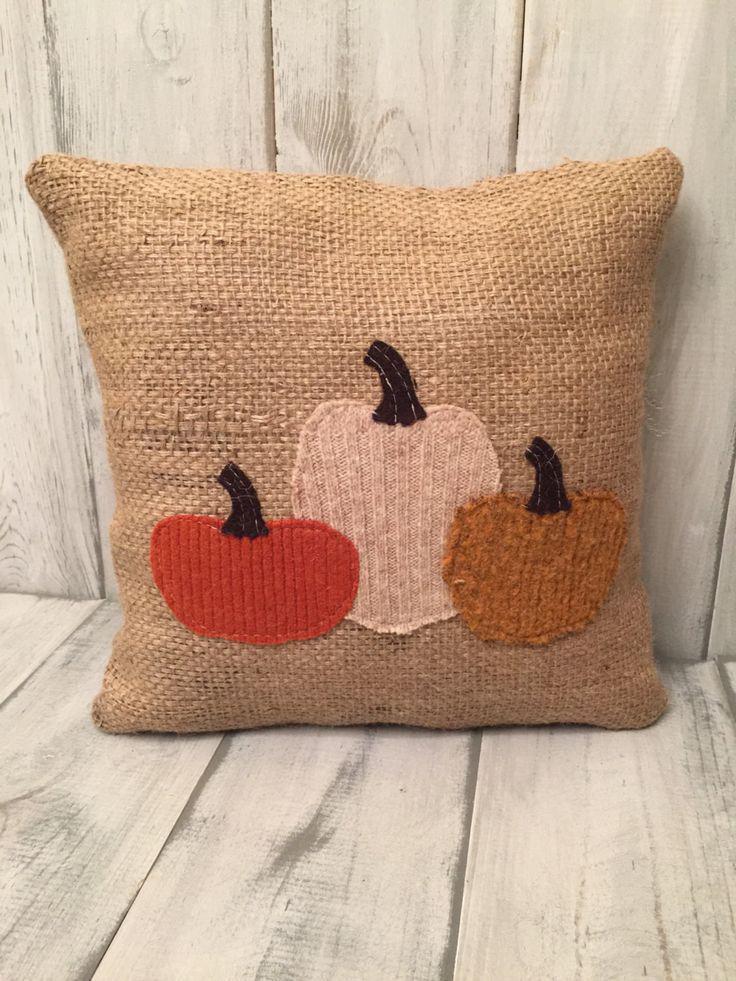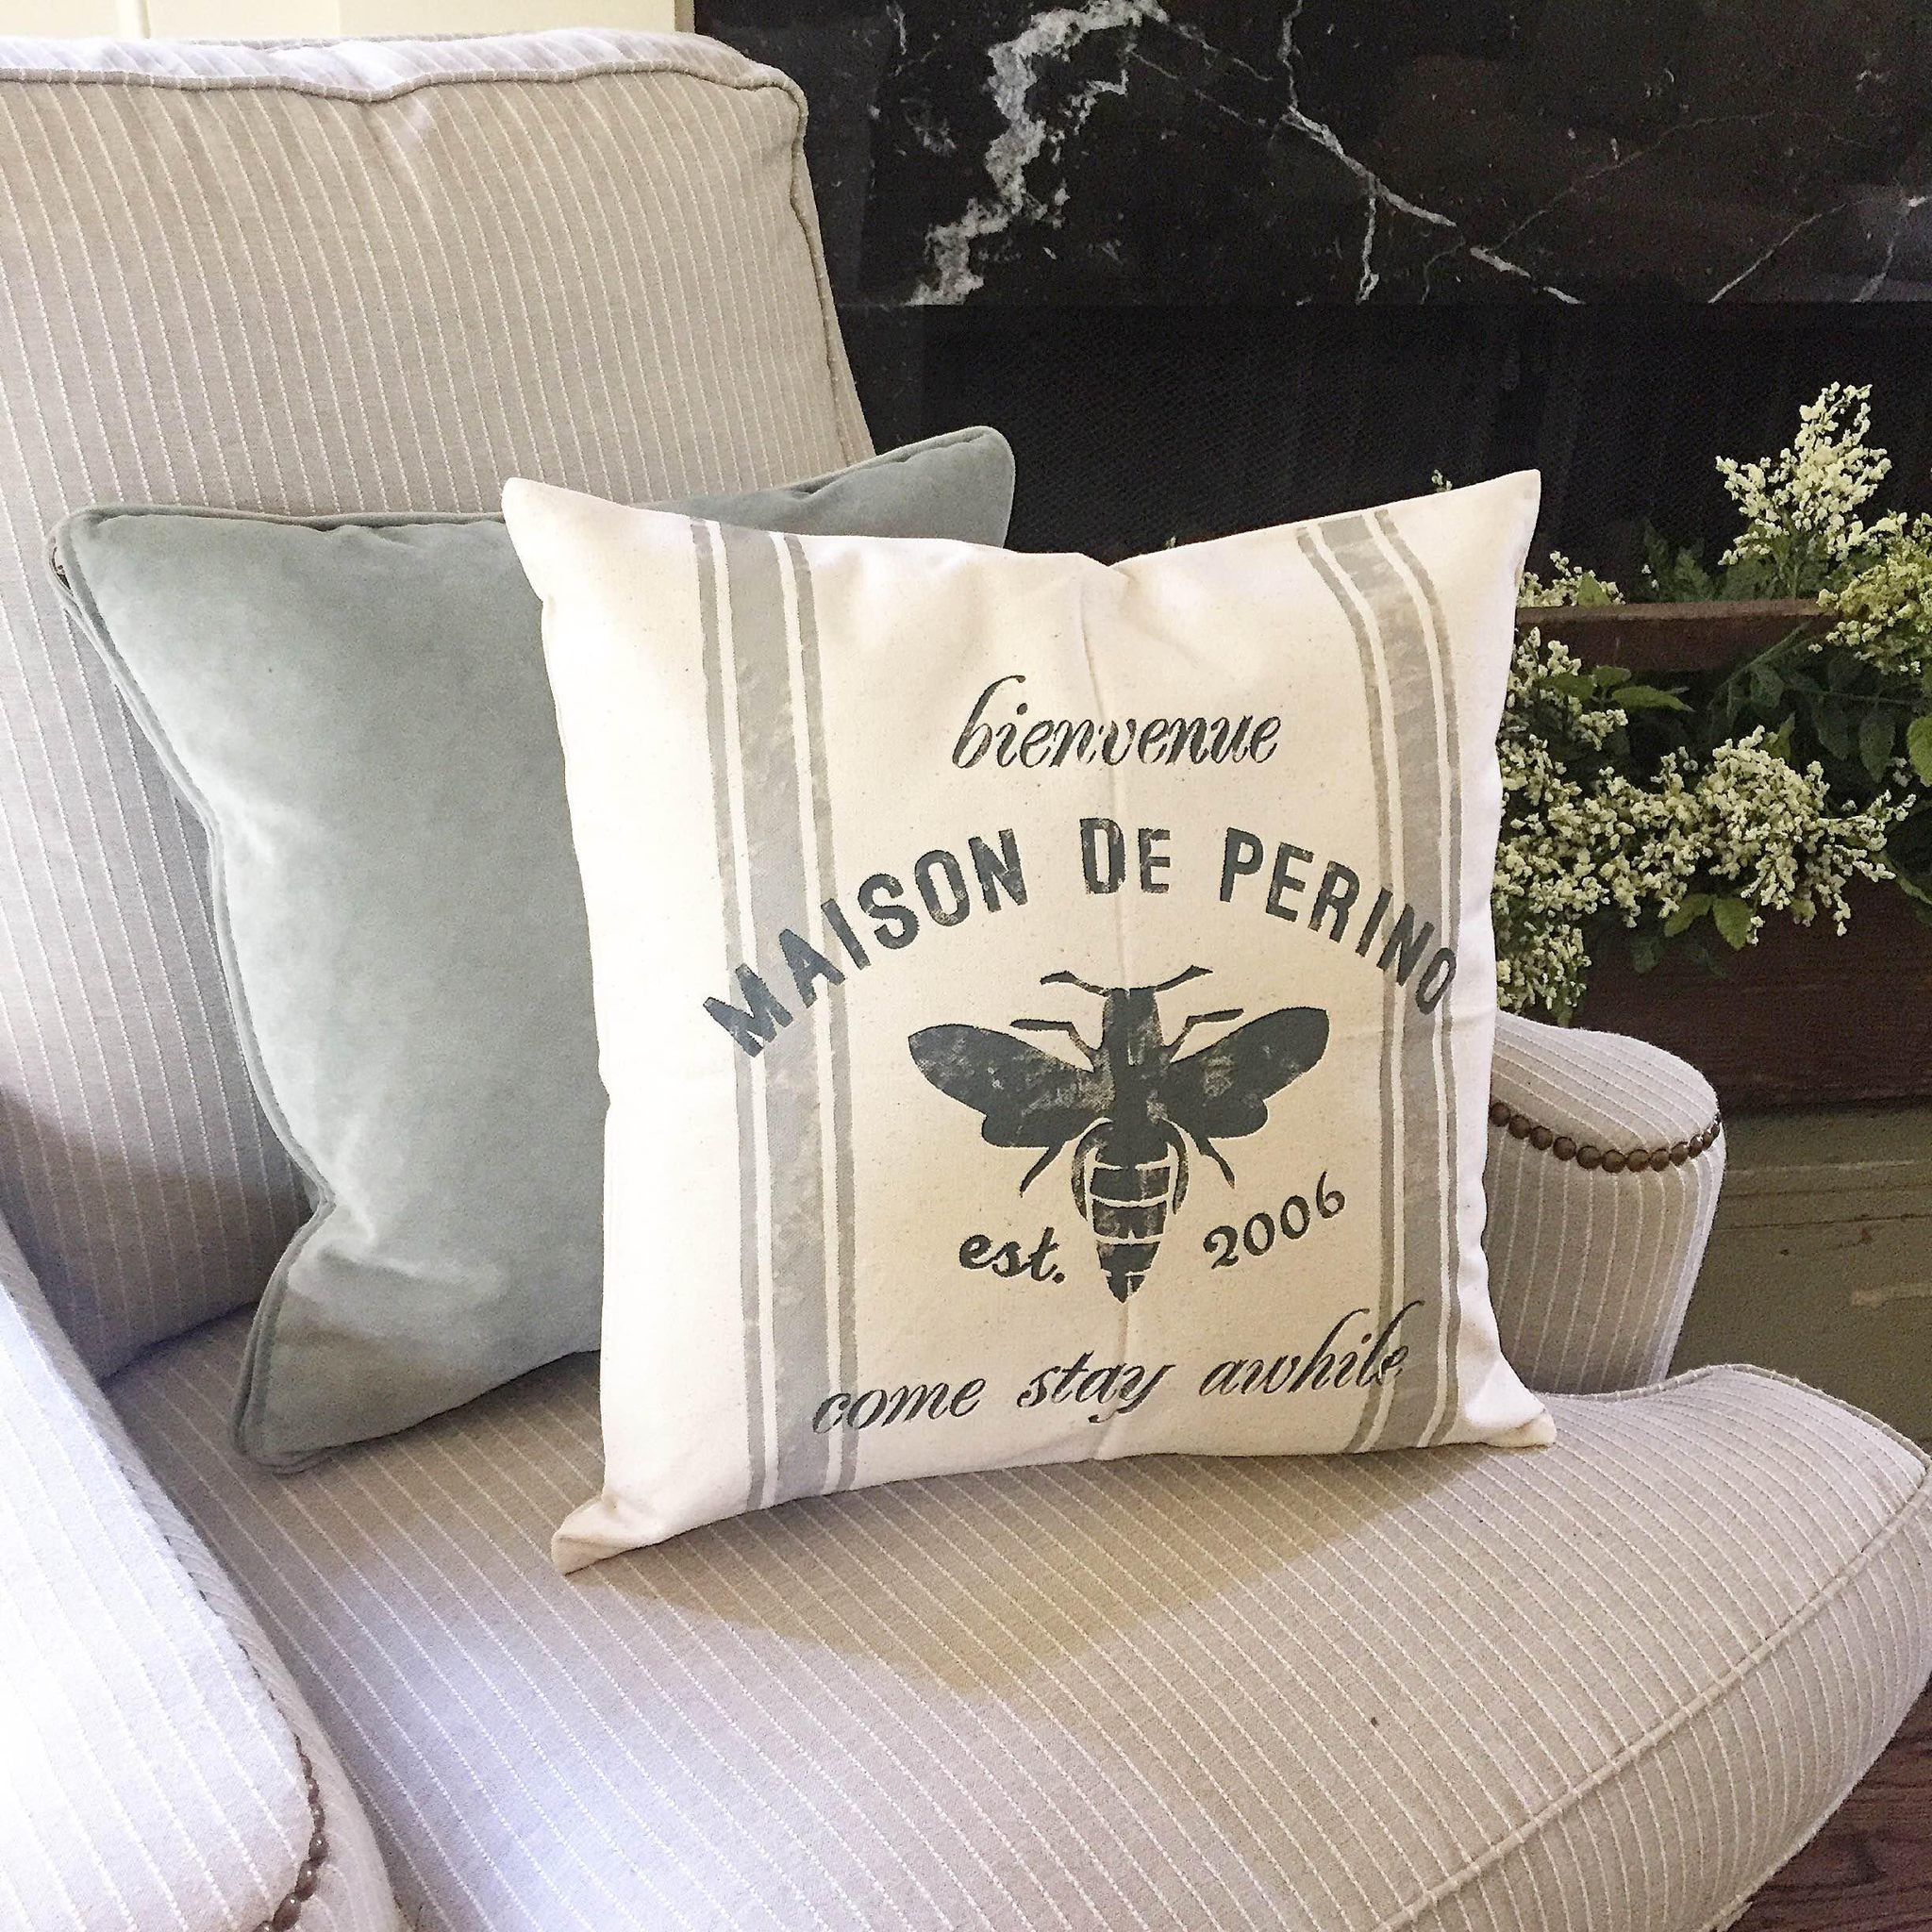The first image is the image on the left, the second image is the image on the right. Examine the images to the left and right. Is the description "A single burlap covered pillow sits on a wooden surface in the image on the left." accurate? Answer yes or no. Yes. The first image is the image on the left, the second image is the image on the right. For the images shown, is this caption "An image shows one square pillow made of burlap decorated with pumpkin shapes." true? Answer yes or no. Yes. 